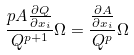Convert formula to latex. <formula><loc_0><loc_0><loc_500><loc_500>\frac { p A \frac { \partial Q } { \partial x _ { i } } } { Q ^ { p + 1 } } \Omega = \frac { \frac { \partial A } { \partial x _ { i } } } { Q ^ { p } } \Omega</formula> 